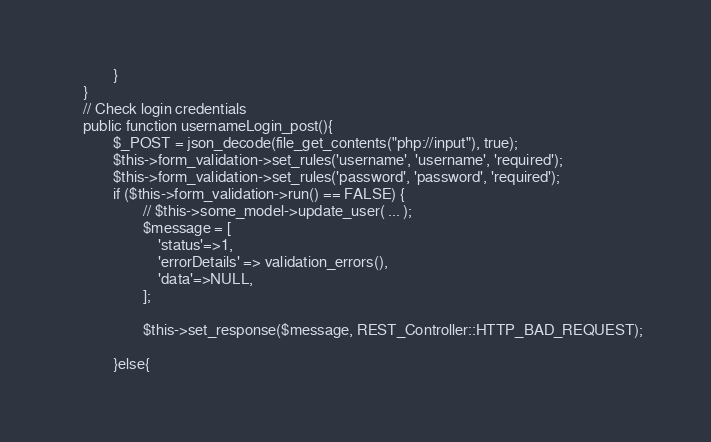Convert code to text. <code><loc_0><loc_0><loc_500><loc_500><_PHP_>            }
    }
    // Check login credentials
    public function usernameLogin_post(){
            $_POST = json_decode(file_get_contents("php://input"), true);
            $this->form_validation->set_rules('username', 'username', 'required'); 
            $this->form_validation->set_rules('password', 'password', 'required'); 
            if ($this->form_validation->run() == FALSE) {   
                    // $this->some_model->update_user( ... );
                    $message = [
                        'status'=>1,
                        'errorDetails' => validation_errors(),
                        'data'=>NULL,
                    ];

                    $this->set_response($message, REST_Controller::HTTP_BAD_REQUEST);
                
            }else{ </code> 